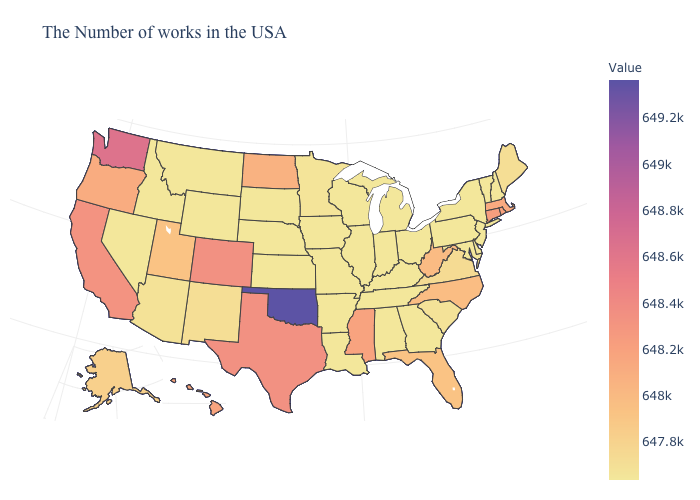Which states have the highest value in the USA?
Concise answer only. Oklahoma. Does the map have missing data?
Be succinct. No. Among the states that border Ohio , does Michigan have the highest value?
Quick response, please. No. Does Utah have the lowest value in the West?
Be succinct. No. Which states have the lowest value in the West?
Be succinct. Wyoming, Montana, Idaho, Nevada. 